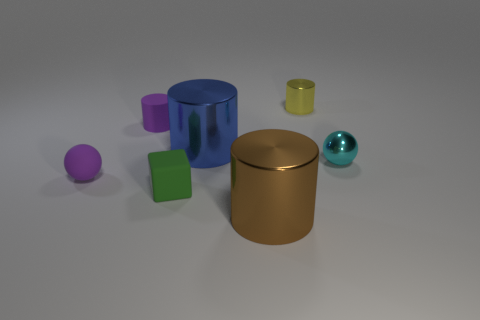There is a brown object that is the same material as the small yellow thing; what size is it?
Your response must be concise. Large. There is a small metal thing behind the tiny metallic object in front of the small shiny cylinder; what is its color?
Provide a short and direct response. Yellow. There is a large blue metallic thing; does it have the same shape as the tiny cyan object that is behind the brown metal cylinder?
Make the answer very short. No. What number of cyan objects have the same size as the brown metallic object?
Your answer should be compact. 0. There is another object that is the same shape as the cyan metallic object; what material is it?
Your answer should be very brief. Rubber. There is a ball to the left of the large brown metal cylinder; does it have the same color as the large metal cylinder in front of the green rubber block?
Your answer should be very brief. No. What is the shape of the small green matte thing in front of the small purple sphere?
Your answer should be compact. Cube. The metallic ball is what color?
Provide a succinct answer. Cyan. There is a green object that is the same material as the purple ball; what is its shape?
Your answer should be very brief. Cube. There is a matte thing that is behind the blue cylinder; does it have the same size as the big brown shiny cylinder?
Your response must be concise. No. 